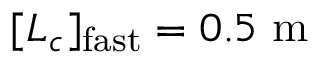<formula> <loc_0><loc_0><loc_500><loc_500>[ L _ { c } ] _ { f a s t } = 0 . 5 \ m</formula> 